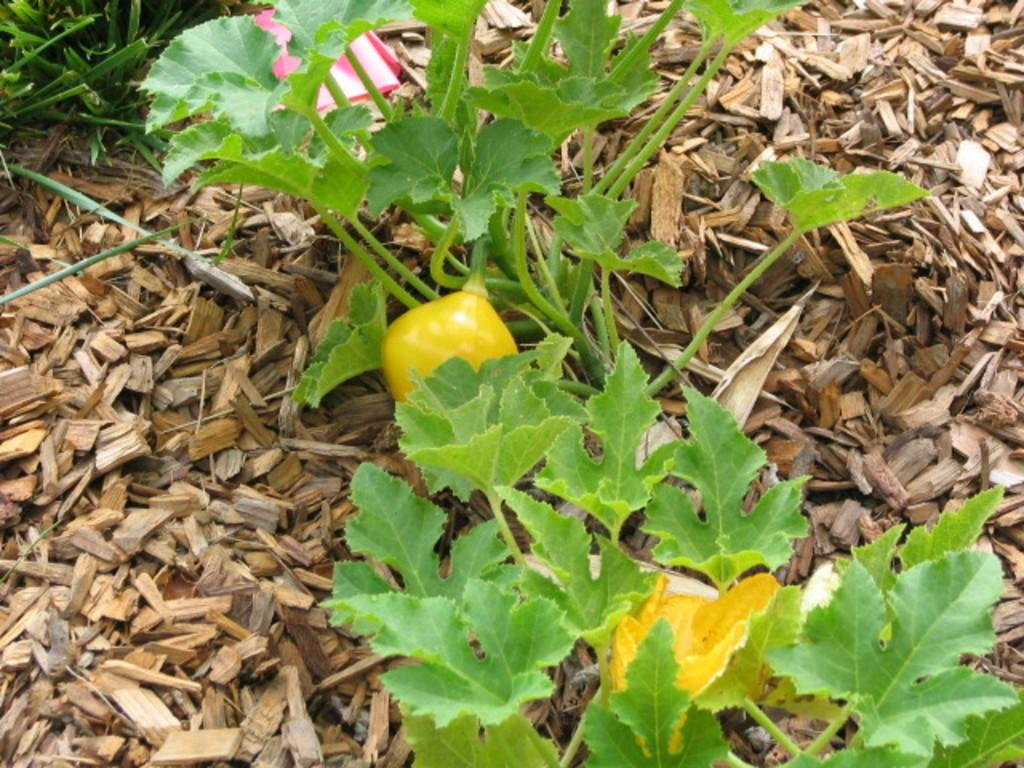What type of plant is in the image? There is a plant in the image with yellow flowers and a yellow fruit. What color are the flowers on the plant? The flowers on the plant are yellow. What is the plant resting on? The plant is on small wooden pieces. What type of vegetation can be seen in the image, other than the plant? There is grass visible in the image, specifically in the left top corner. How long does it take for the plant to grow a new fruit in the image? The image does not provide information about the growth rate of the plant, so it is impossible to determine how long it takes for the plant to grow a new fruit. 